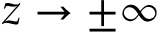Convert formula to latex. <formula><loc_0><loc_0><loc_500><loc_500>z \rightarrow \pm \infty</formula> 